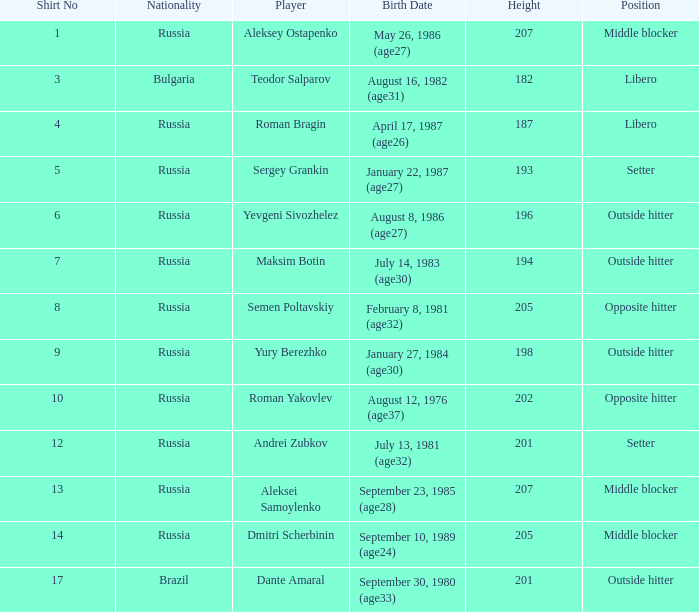What is roman bragin's title? Libero. 